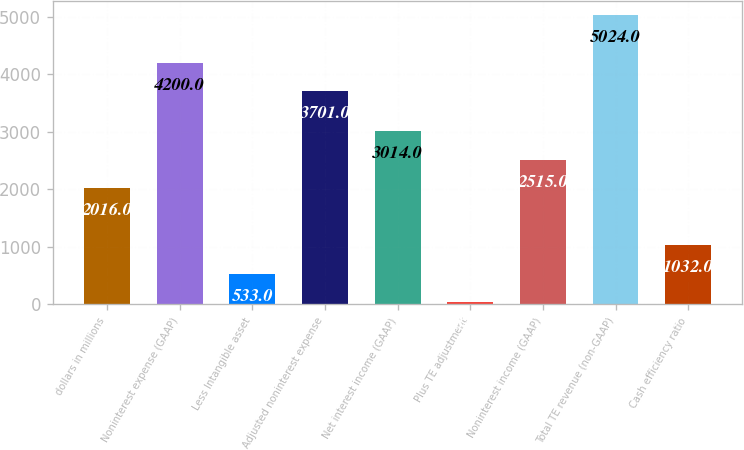<chart> <loc_0><loc_0><loc_500><loc_500><bar_chart><fcel>dollars in millions<fcel>Noninterest expense (GAAP)<fcel>Less Intangible asset<fcel>Adjusted noninterest expense<fcel>Net interest income (GAAP)<fcel>Plus TE adjustment<fcel>Noninterest income (GAAP)<fcel>Total TE revenue (non-GAAP)<fcel>Cash efficiency ratio<nl><fcel>2016<fcel>4200<fcel>533<fcel>3701<fcel>3014<fcel>34<fcel>2515<fcel>5024<fcel>1032<nl></chart> 